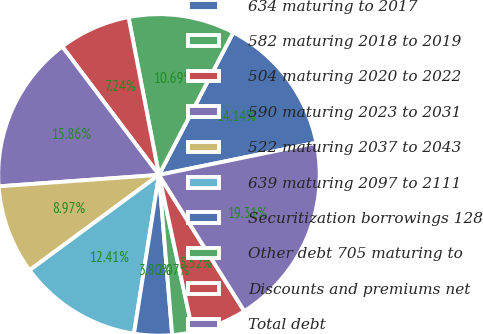Convert chart to OTSL. <chart><loc_0><loc_0><loc_500><loc_500><pie_chart><fcel>634 maturing to 2017<fcel>582 maturing 2018 to 2019<fcel>504 maturing 2020 to 2022<fcel>590 maturing 2023 to 2031<fcel>522 maturing 2037 to 2043<fcel>639 maturing 2097 to 2111<fcel>Securitization borrowings 128<fcel>Other debt 705 maturing to<fcel>Discounts and premiums net<fcel>Total debt<nl><fcel>14.14%<fcel>10.69%<fcel>7.24%<fcel>15.86%<fcel>8.97%<fcel>12.41%<fcel>3.8%<fcel>2.07%<fcel>5.52%<fcel>19.31%<nl></chart> 